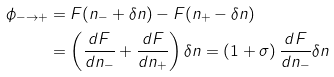Convert formula to latex. <formula><loc_0><loc_0><loc_500><loc_500>\phi _ { - \to + } & = F ( n _ { - } + \delta n ) - F ( n _ { + } - \delta n ) \\ & = \left ( \frac { d F } { d n _ { - } } + \frac { d F } { d n _ { + } } \right ) \delta n = \left ( 1 + \sigma \right ) \frac { d F } { d n _ { - } } \delta n</formula> 